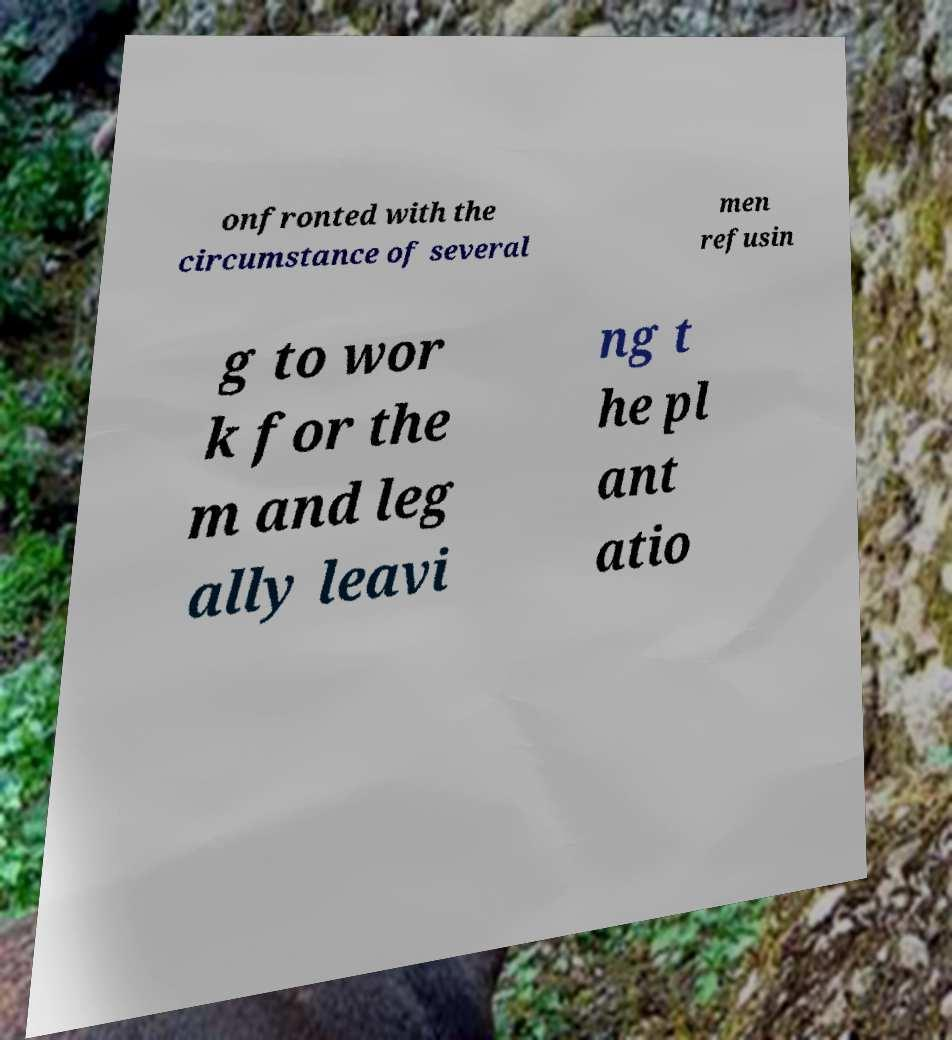For documentation purposes, I need the text within this image transcribed. Could you provide that? onfronted with the circumstance of several men refusin g to wor k for the m and leg ally leavi ng t he pl ant atio 